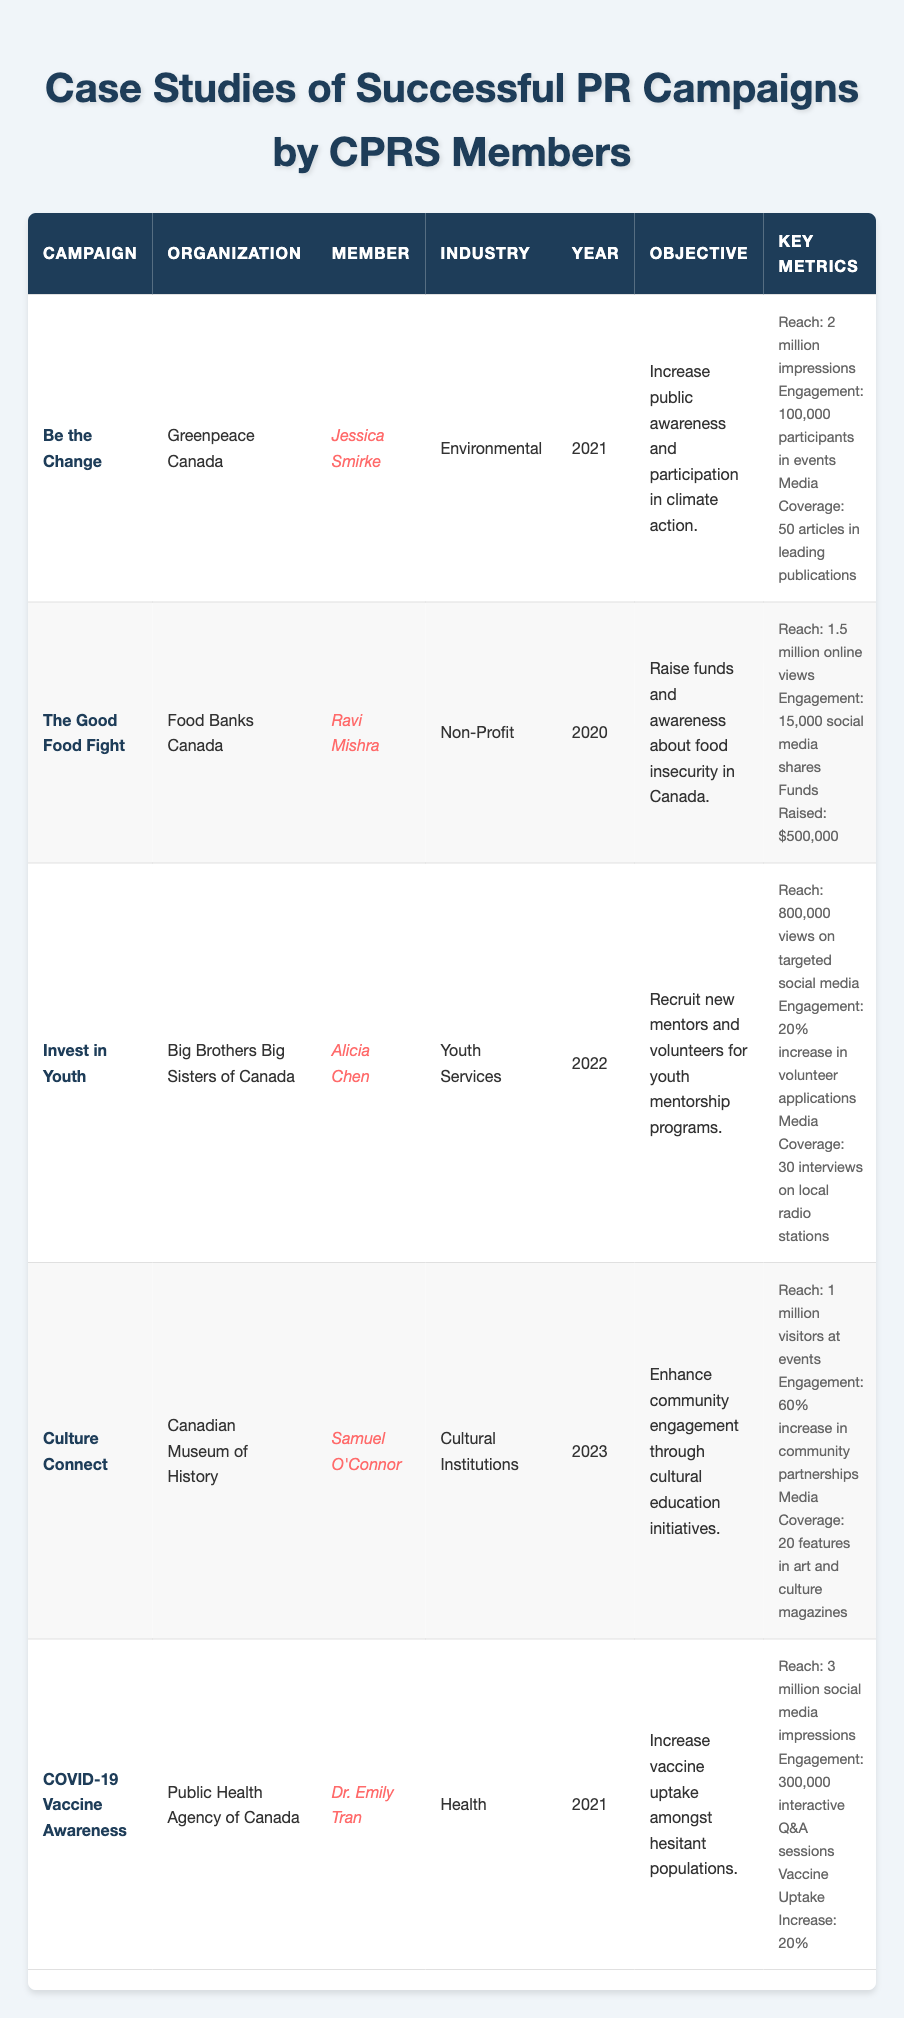What was the objective of the "Invest in Youth" campaign? The objective is listed in the table under the "Objective" column for the "Invest in Youth" campaign. It states: "Recruit new mentors and volunteers for youth mentorship programs."
Answer: Recruit new mentors and volunteers for youth mentorship programs Who was the member associated with the "Be the Change" campaign? The member's name is provided in the "Member" column for the "Be the Change" campaign. It is Jessica Smirke.
Answer: Jessica Smirke How many articles covered the "Be the Change" campaign? The "Key Metrics" column for the "Be the Change" campaign indicates that there were "50 articles in leading publications."
Answer: 50 articles Did the "Culture Connect" campaign occur before 2023? The year listed for the "Culture Connect" campaign is 2023, which means it did not occur before that year. Therefore, the statement is false.
Answer: No Which campaign had the highest reach according to the table? To determine which campaign had the highest reach, we compare the reach metrics: "Be the Change" (2 million), "The Good Food Fight" (1.5 million), "Invest in Youth" (800,000), "Culture Connect" (1 million), and "COVID-19 Vaccine Awareness" (3 million). The highest reach is from "COVID-19 Vaccine Awareness" with 3 million.
Answer: COVID-19 Vaccine Awareness What percentage increase in volunteer applications did the "Invest in Youth" campaign achieve? The "Key Metrics" section for the "Invest in Youth" campaign states there was a "20% increase in volunteer applications."
Answer: 20% Which two campaigns had a focus on increasing community engagement or participation? The table shows that the "Be the Change" campaign aimed to "Increase public awareness and participation in climate action" and the "Culture Connect" campaign aimed to "Enhance community engagement through cultural education initiatives." Both campaigns focus on community engagement.
Answer: Be the Change and Culture Connect What was the total amount of funds raised by the "Good Food Fight" campaign? The funds raised are clearly stated in the "Key Metrics" column, which mentions "$500,000" for the "Good Food Fight" campaign.
Answer: $500,000 